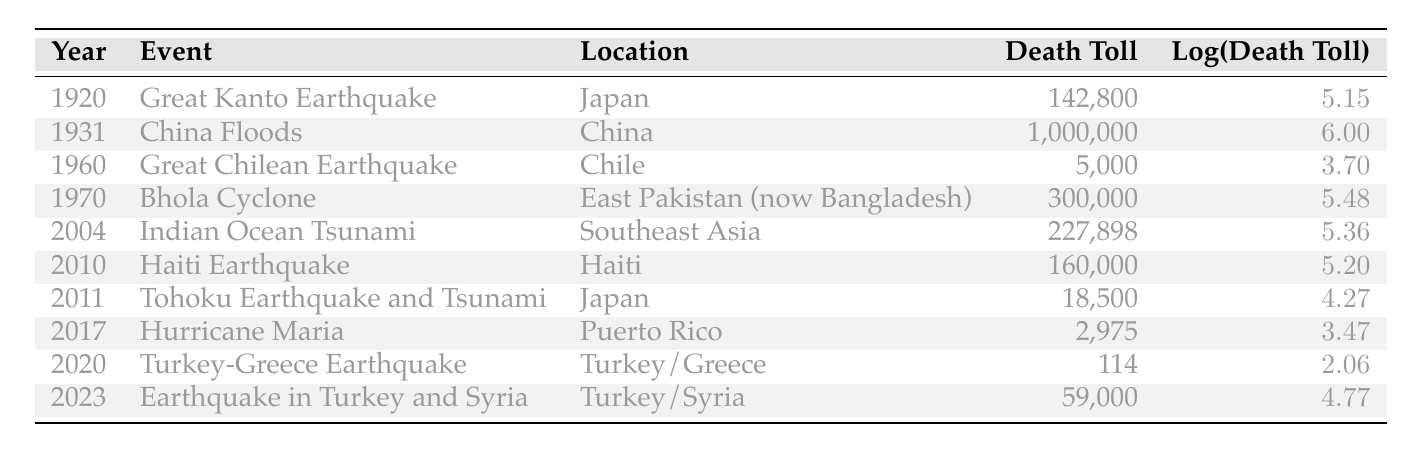What was the death toll of the China Floods in 1931? The table lists the death toll for the China Floods in the year 1931 as 1,000,000.
Answer: 1,000,000 Which event had the highest death toll and what was that toll? By examining the table, the event with the highest death toll is the China Floods in 1931 with a toll of 1,000,000.
Answer: China Floods in 1931, 1,000,000 What is the log of the death toll for the Great Kanto Earthquake in 1920? The log of the death toll for the Great Kanto Earthquake in 1920 is given in the table as 5.15.
Answer: 5.15 How many natural disasters listed resulted in a death toll above 200,000? From the table, there are three events with a death toll above 200,000: China Floods (1,000,000), Bhola Cyclone (300,000), and Great Kanto Earthquake (142,800).
Answer: 3 What is the average death toll for the natural disasters listed from 1920 to 2023? First, we sum the death tolls: 142800 + 1000000 + 5000 + 300000 + 227898 + 160000 + 18500 + 2975 + 114 + 59000 = 1,705,287. There are 10 data points, so the average is 1,705,287 / 10 = 170,528.7.
Answer: 170,528.7 Was the death toll from Hurricane Maria in 2017 less than the death toll from the Tohoku Earthquake in 2011? The table shows that the death toll for Hurricane Maria in 2017 was 2975, while the Tohoku Earthquake in 2011 had a death toll of 18,500. Since 2975 < 18,500, the statement is true.
Answer: Yes What year experienced the second highest death toll from natural disasters in the table? According to the table, the year that experienced the second highest death toll is 1970 with the Bhola Cyclone having a death toll of 300,000, coming after the 1931 China Floods.
Answer: 1970 How many disasters recorded in the table occurred in Japan? Looking through the table, the Great Kanto Earthquake (1920) and the Tohoku Earthquake and Tsunami (2011) occurred in Japan, totaling 2 events.
Answer: 2 What is the difference in death toll between the Bhola Cyclone and the Haitian Earthquake? The table shows the death toll for the Bhola Cyclone as 300,000 and for the Haitian Earthquake as 160,000. The difference is calculated as 300,000 - 160,000 = 140,000.
Answer: 140,000 